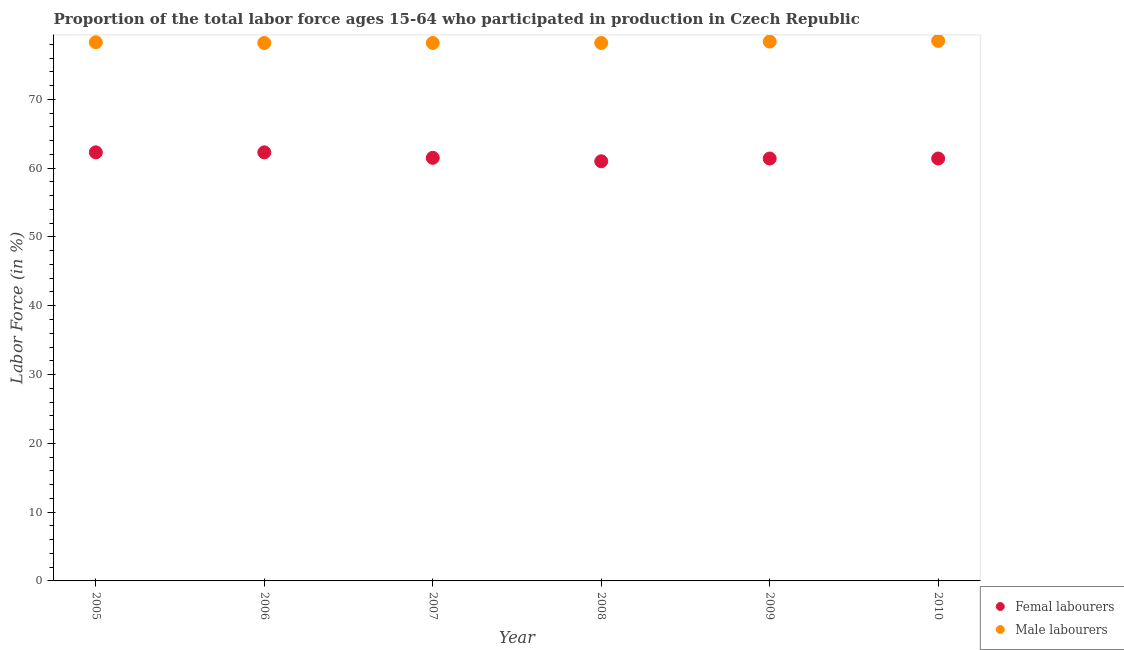How many different coloured dotlines are there?
Ensure brevity in your answer.  2. Is the number of dotlines equal to the number of legend labels?
Your response must be concise. Yes. What is the percentage of male labour force in 2009?
Ensure brevity in your answer.  78.4. Across all years, what is the maximum percentage of male labour force?
Offer a terse response. 78.5. Across all years, what is the minimum percentage of male labour force?
Provide a short and direct response. 78.2. What is the total percentage of female labor force in the graph?
Your response must be concise. 369.9. What is the difference between the percentage of female labor force in 2007 and that in 2010?
Make the answer very short. 0.1. What is the difference between the percentage of female labor force in 2006 and the percentage of male labour force in 2008?
Give a very brief answer. -15.9. What is the average percentage of male labour force per year?
Your answer should be compact. 78.3. In the year 2005, what is the difference between the percentage of female labor force and percentage of male labour force?
Ensure brevity in your answer.  -16. What is the ratio of the percentage of male labour force in 2008 to that in 2009?
Provide a succinct answer. 1. Is the difference between the percentage of male labour force in 2007 and 2010 greater than the difference between the percentage of female labor force in 2007 and 2010?
Provide a short and direct response. No. What is the difference between the highest and the lowest percentage of female labor force?
Offer a very short reply. 1.3. In how many years, is the percentage of male labour force greater than the average percentage of male labour force taken over all years?
Your answer should be compact. 3. Is the sum of the percentage of female labor force in 2007 and 2008 greater than the maximum percentage of male labour force across all years?
Give a very brief answer. Yes. Is the percentage of female labor force strictly less than the percentage of male labour force over the years?
Provide a succinct answer. Yes. How many dotlines are there?
Keep it short and to the point. 2. Does the graph contain any zero values?
Provide a succinct answer. No. Does the graph contain grids?
Offer a terse response. No. Where does the legend appear in the graph?
Offer a very short reply. Bottom right. How many legend labels are there?
Your answer should be very brief. 2. What is the title of the graph?
Offer a terse response. Proportion of the total labor force ages 15-64 who participated in production in Czech Republic. What is the Labor Force (in %) of Femal labourers in 2005?
Offer a terse response. 62.3. What is the Labor Force (in %) of Male labourers in 2005?
Ensure brevity in your answer.  78.3. What is the Labor Force (in %) in Femal labourers in 2006?
Keep it short and to the point. 62.3. What is the Labor Force (in %) in Male labourers in 2006?
Provide a succinct answer. 78.2. What is the Labor Force (in %) in Femal labourers in 2007?
Provide a succinct answer. 61.5. What is the Labor Force (in %) of Male labourers in 2007?
Make the answer very short. 78.2. What is the Labor Force (in %) of Male labourers in 2008?
Offer a very short reply. 78.2. What is the Labor Force (in %) of Femal labourers in 2009?
Ensure brevity in your answer.  61.4. What is the Labor Force (in %) of Male labourers in 2009?
Offer a very short reply. 78.4. What is the Labor Force (in %) in Femal labourers in 2010?
Offer a terse response. 61.4. What is the Labor Force (in %) in Male labourers in 2010?
Provide a short and direct response. 78.5. Across all years, what is the maximum Labor Force (in %) in Femal labourers?
Your answer should be compact. 62.3. Across all years, what is the maximum Labor Force (in %) of Male labourers?
Your answer should be compact. 78.5. Across all years, what is the minimum Labor Force (in %) of Femal labourers?
Your answer should be compact. 61. Across all years, what is the minimum Labor Force (in %) in Male labourers?
Ensure brevity in your answer.  78.2. What is the total Labor Force (in %) in Femal labourers in the graph?
Your answer should be compact. 369.9. What is the total Labor Force (in %) in Male labourers in the graph?
Provide a short and direct response. 469.8. What is the difference between the Labor Force (in %) of Femal labourers in 2005 and that in 2006?
Your answer should be very brief. 0. What is the difference between the Labor Force (in %) of Male labourers in 2005 and that in 2006?
Make the answer very short. 0.1. What is the difference between the Labor Force (in %) in Male labourers in 2005 and that in 2007?
Your answer should be compact. 0.1. What is the difference between the Labor Force (in %) of Male labourers in 2005 and that in 2010?
Keep it short and to the point. -0.2. What is the difference between the Labor Force (in %) in Femal labourers in 2006 and that in 2007?
Provide a succinct answer. 0.8. What is the difference between the Labor Force (in %) in Male labourers in 2006 and that in 2007?
Your answer should be very brief. 0. What is the difference between the Labor Force (in %) of Femal labourers in 2006 and that in 2008?
Ensure brevity in your answer.  1.3. What is the difference between the Labor Force (in %) of Male labourers in 2006 and that in 2008?
Your answer should be very brief. 0. What is the difference between the Labor Force (in %) in Femal labourers in 2006 and that in 2009?
Your answer should be very brief. 0.9. What is the difference between the Labor Force (in %) of Male labourers in 2006 and that in 2009?
Your response must be concise. -0.2. What is the difference between the Labor Force (in %) in Femal labourers in 2006 and that in 2010?
Provide a succinct answer. 0.9. What is the difference between the Labor Force (in %) in Male labourers in 2007 and that in 2008?
Your answer should be very brief. 0. What is the difference between the Labor Force (in %) of Femal labourers in 2007 and that in 2009?
Your answer should be very brief. 0.1. What is the difference between the Labor Force (in %) of Male labourers in 2007 and that in 2009?
Provide a short and direct response. -0.2. What is the difference between the Labor Force (in %) in Femal labourers in 2007 and that in 2010?
Your response must be concise. 0.1. What is the difference between the Labor Force (in %) of Femal labourers in 2009 and that in 2010?
Ensure brevity in your answer.  0. What is the difference between the Labor Force (in %) in Femal labourers in 2005 and the Labor Force (in %) in Male labourers in 2006?
Make the answer very short. -15.9. What is the difference between the Labor Force (in %) of Femal labourers in 2005 and the Labor Force (in %) of Male labourers in 2007?
Your response must be concise. -15.9. What is the difference between the Labor Force (in %) of Femal labourers in 2005 and the Labor Force (in %) of Male labourers in 2008?
Your answer should be compact. -15.9. What is the difference between the Labor Force (in %) of Femal labourers in 2005 and the Labor Force (in %) of Male labourers in 2009?
Provide a succinct answer. -16.1. What is the difference between the Labor Force (in %) in Femal labourers in 2005 and the Labor Force (in %) in Male labourers in 2010?
Your answer should be very brief. -16.2. What is the difference between the Labor Force (in %) in Femal labourers in 2006 and the Labor Force (in %) in Male labourers in 2007?
Your answer should be very brief. -15.9. What is the difference between the Labor Force (in %) of Femal labourers in 2006 and the Labor Force (in %) of Male labourers in 2008?
Your answer should be very brief. -15.9. What is the difference between the Labor Force (in %) in Femal labourers in 2006 and the Labor Force (in %) in Male labourers in 2009?
Give a very brief answer. -16.1. What is the difference between the Labor Force (in %) in Femal labourers in 2006 and the Labor Force (in %) in Male labourers in 2010?
Your response must be concise. -16.2. What is the difference between the Labor Force (in %) of Femal labourers in 2007 and the Labor Force (in %) of Male labourers in 2008?
Offer a terse response. -16.7. What is the difference between the Labor Force (in %) of Femal labourers in 2007 and the Labor Force (in %) of Male labourers in 2009?
Offer a terse response. -16.9. What is the difference between the Labor Force (in %) of Femal labourers in 2008 and the Labor Force (in %) of Male labourers in 2009?
Provide a short and direct response. -17.4. What is the difference between the Labor Force (in %) of Femal labourers in 2008 and the Labor Force (in %) of Male labourers in 2010?
Your answer should be very brief. -17.5. What is the difference between the Labor Force (in %) of Femal labourers in 2009 and the Labor Force (in %) of Male labourers in 2010?
Your answer should be compact. -17.1. What is the average Labor Force (in %) in Femal labourers per year?
Your response must be concise. 61.65. What is the average Labor Force (in %) of Male labourers per year?
Provide a short and direct response. 78.3. In the year 2006, what is the difference between the Labor Force (in %) of Femal labourers and Labor Force (in %) of Male labourers?
Offer a very short reply. -15.9. In the year 2007, what is the difference between the Labor Force (in %) in Femal labourers and Labor Force (in %) in Male labourers?
Your answer should be compact. -16.7. In the year 2008, what is the difference between the Labor Force (in %) of Femal labourers and Labor Force (in %) of Male labourers?
Make the answer very short. -17.2. In the year 2010, what is the difference between the Labor Force (in %) of Femal labourers and Labor Force (in %) of Male labourers?
Your answer should be compact. -17.1. What is the ratio of the Labor Force (in %) in Femal labourers in 2005 to that in 2007?
Your response must be concise. 1.01. What is the ratio of the Labor Force (in %) of Male labourers in 2005 to that in 2007?
Ensure brevity in your answer.  1. What is the ratio of the Labor Force (in %) of Femal labourers in 2005 to that in 2008?
Offer a terse response. 1.02. What is the ratio of the Labor Force (in %) in Femal labourers in 2005 to that in 2009?
Offer a terse response. 1.01. What is the ratio of the Labor Force (in %) of Male labourers in 2005 to that in 2009?
Offer a very short reply. 1. What is the ratio of the Labor Force (in %) in Femal labourers in 2005 to that in 2010?
Offer a terse response. 1.01. What is the ratio of the Labor Force (in %) of Femal labourers in 2006 to that in 2007?
Make the answer very short. 1.01. What is the ratio of the Labor Force (in %) of Male labourers in 2006 to that in 2007?
Your response must be concise. 1. What is the ratio of the Labor Force (in %) of Femal labourers in 2006 to that in 2008?
Offer a terse response. 1.02. What is the ratio of the Labor Force (in %) in Male labourers in 2006 to that in 2008?
Keep it short and to the point. 1. What is the ratio of the Labor Force (in %) in Femal labourers in 2006 to that in 2009?
Offer a very short reply. 1.01. What is the ratio of the Labor Force (in %) of Femal labourers in 2006 to that in 2010?
Keep it short and to the point. 1.01. What is the ratio of the Labor Force (in %) in Femal labourers in 2007 to that in 2008?
Your answer should be very brief. 1.01. What is the ratio of the Labor Force (in %) of Male labourers in 2007 to that in 2008?
Give a very brief answer. 1. What is the ratio of the Labor Force (in %) of Femal labourers in 2007 to that in 2009?
Offer a terse response. 1. What is the ratio of the Labor Force (in %) of Male labourers in 2007 to that in 2009?
Ensure brevity in your answer.  1. What is the ratio of the Labor Force (in %) of Male labourers in 2007 to that in 2010?
Provide a short and direct response. 1. What is the ratio of the Labor Force (in %) in Femal labourers in 2008 to that in 2009?
Your answer should be very brief. 0.99. What is the ratio of the Labor Force (in %) of Male labourers in 2008 to that in 2009?
Provide a short and direct response. 1. What is the ratio of the Labor Force (in %) in Femal labourers in 2008 to that in 2010?
Your answer should be compact. 0.99. What is the ratio of the Labor Force (in %) in Male labourers in 2008 to that in 2010?
Offer a terse response. 1. What is the ratio of the Labor Force (in %) of Male labourers in 2009 to that in 2010?
Your answer should be very brief. 1. What is the difference between the highest and the second highest Labor Force (in %) of Femal labourers?
Provide a succinct answer. 0. What is the difference between the highest and the second highest Labor Force (in %) in Male labourers?
Provide a short and direct response. 0.1. What is the difference between the highest and the lowest Labor Force (in %) of Femal labourers?
Your response must be concise. 1.3. 